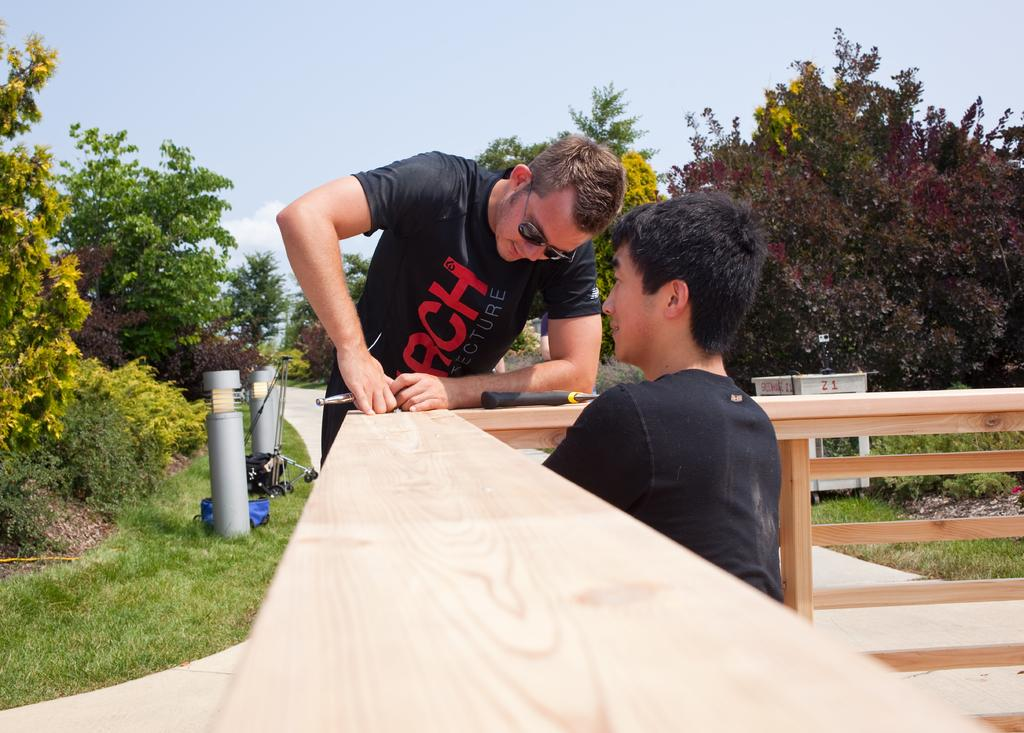How many people are in the image? There are two persons in the image. What can be seen in the background of the image? There are trees in the background of the image. What type of vegetation is visible in the image? There is grass visible in the image. What is visible at the top of the image? The sky is visible at the top of the image. What material is present in the image? There is wood present in the image. How many snails can be seen crawling on the wood in the image? There are no snails visible in the image; only the two persons, trees, grass, sky, and wood are present. What type of laborer is working on the boat in the image? There is no boat or laborer present in the image. 